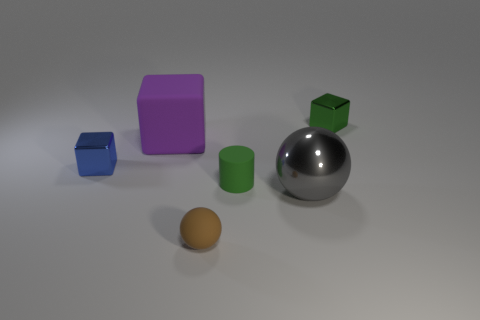Add 2 purple metallic spheres. How many objects exist? 8 Subtract all balls. How many objects are left? 4 Subtract all big things. Subtract all large green balls. How many objects are left? 4 Add 4 tiny green shiny things. How many tiny green shiny things are left? 5 Add 3 small brown spheres. How many small brown spheres exist? 4 Subtract 0 cyan blocks. How many objects are left? 6 